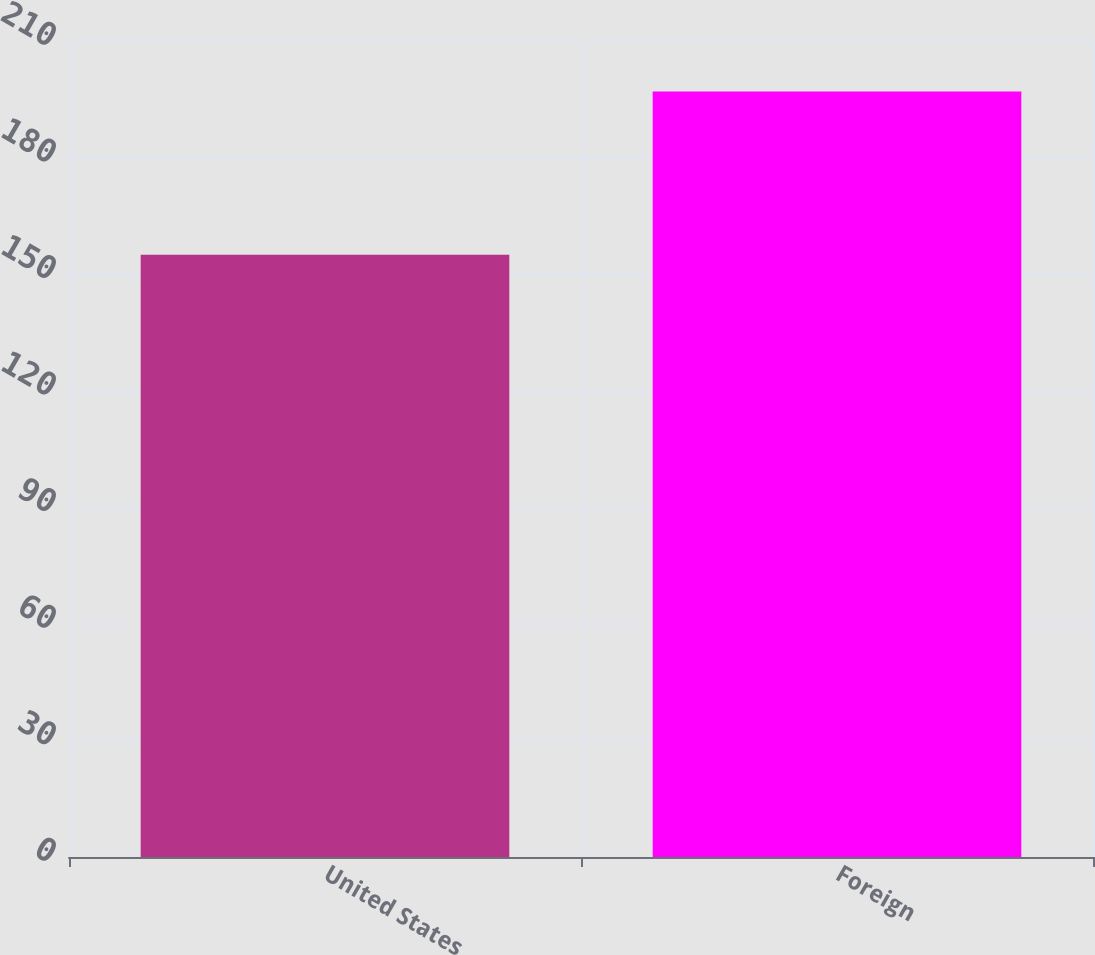Convert chart to OTSL. <chart><loc_0><loc_0><loc_500><loc_500><bar_chart><fcel>United States<fcel>Foreign<nl><fcel>155<fcel>197<nl></chart> 